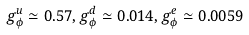Convert formula to latex. <formula><loc_0><loc_0><loc_500><loc_500>g _ { \phi } ^ { u } \simeq 0 . 5 7 , g _ { \phi } ^ { d } \simeq 0 . 0 1 4 , g _ { \phi } ^ { e } \simeq 0 . 0 0 5 9</formula> 